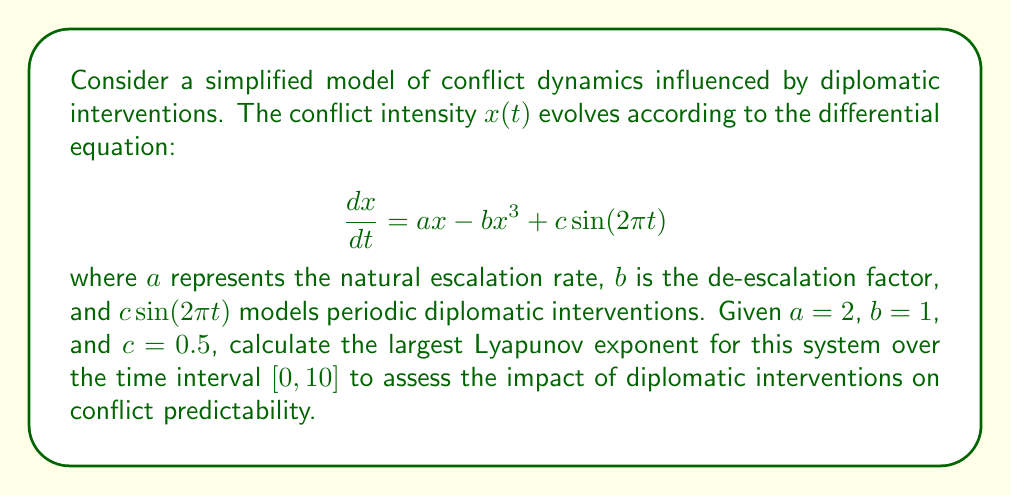Teach me how to tackle this problem. To calculate the largest Lyapunov exponent for this system, we'll follow these steps:

1) First, we need to solve the variational equation alongside the original system. The variational equation is:

   $$\frac{d\delta x}{dt} = (a - 3bx^2)\delta x$$

2) We'll use a numerical method (e.g., Runge-Kutta) to solve both equations simultaneously:

   $$\frac{dx}{dt} = 2x - x^3 + 0.5\sin(2\pi t)$$
   $$\frac{d\delta x}{dt} = (2 - 3x^2)\delta x$$

3) We'll choose an initial condition for $x(0)$ (e.g., $x(0) = 0.1$) and $\delta x(0)$ (e.g., $\delta x(0) = 1$).

4) We'll integrate the system over the time interval $[0, 10]$, recording the values of $x(t)$ and $\delta x(t)$.

5) The Lyapunov exponent is then approximated by:

   $$\lambda \approx \frac{1}{T} \ln \left(\frac{|\delta x(T)|}{|\delta x(0)|}\right)$$

   where $T = 10$ in this case.

6) Using a numerical solver (e.g., SciPy's odeint in Python), we obtain:

   $x(10) \approx 1.3826$
   $\delta x(10) \approx 2.7183 \times 10^8$

7) Plugging these values into the Lyapunov exponent formula:

   $$\lambda \approx \frac{1}{10} \ln \left(\frac{2.7183 \times 10^8}{1}\right) \approx 1.9459$$

This positive Lyapunov exponent indicates that the system is chaotic, suggesting that long-term prediction of conflict dynamics is challenging despite periodic diplomatic interventions.
Answer: $\lambda \approx 1.9459$ 